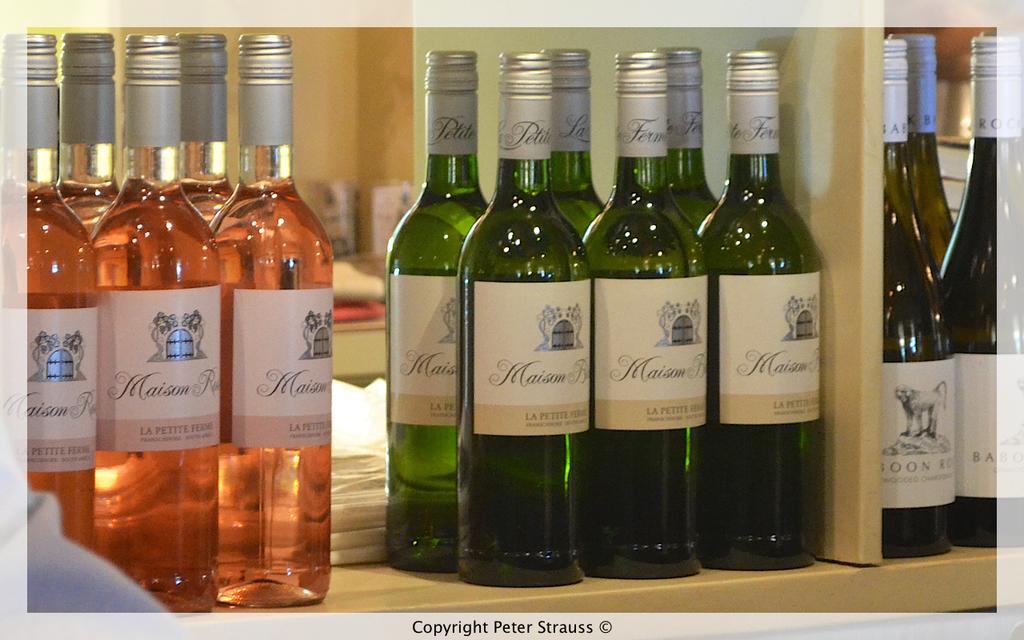What wine type is that?
Provide a succinct answer. Maison. 